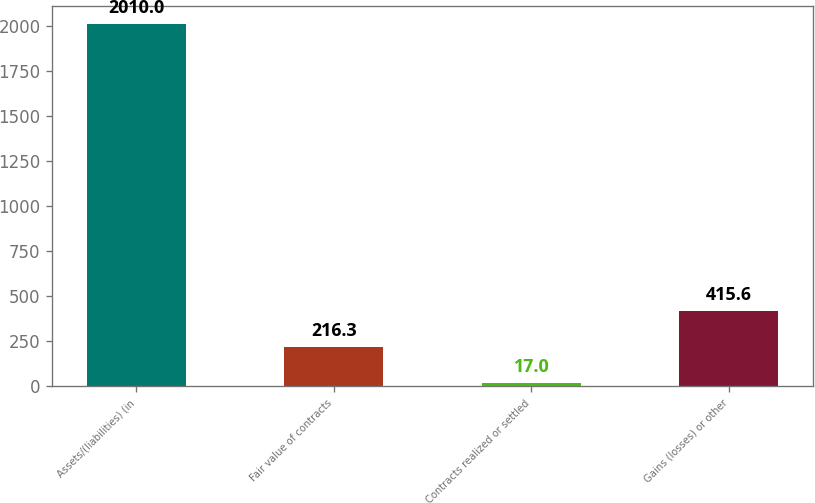<chart> <loc_0><loc_0><loc_500><loc_500><bar_chart><fcel>Assets/(liabilities) (in<fcel>Fair value of contracts<fcel>Contracts realized or settled<fcel>Gains (losses) or other<nl><fcel>2010<fcel>216.3<fcel>17<fcel>415.6<nl></chart> 